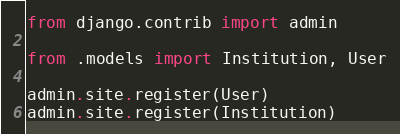<code> <loc_0><loc_0><loc_500><loc_500><_Python_>from django.contrib import admin

from .models import Institution, User

admin.site.register(User)
admin.site.register(Institution)
</code> 